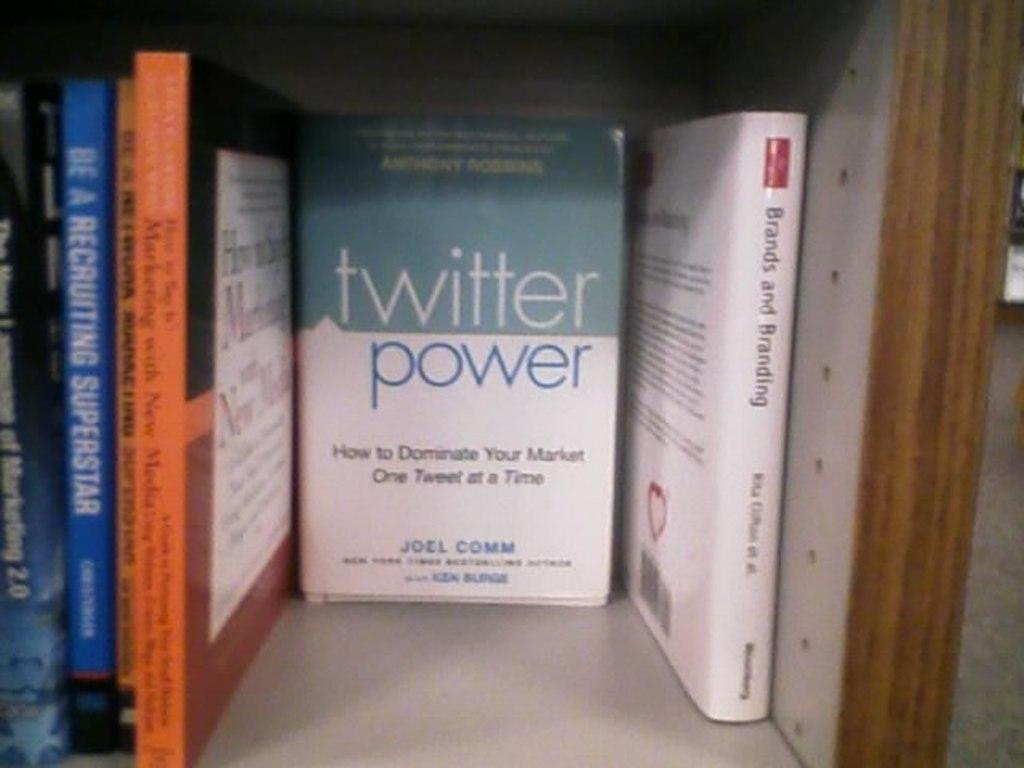<image>
Give a short and clear explanation of the subsequent image. A book titled twitter power is surrounded by other books. 